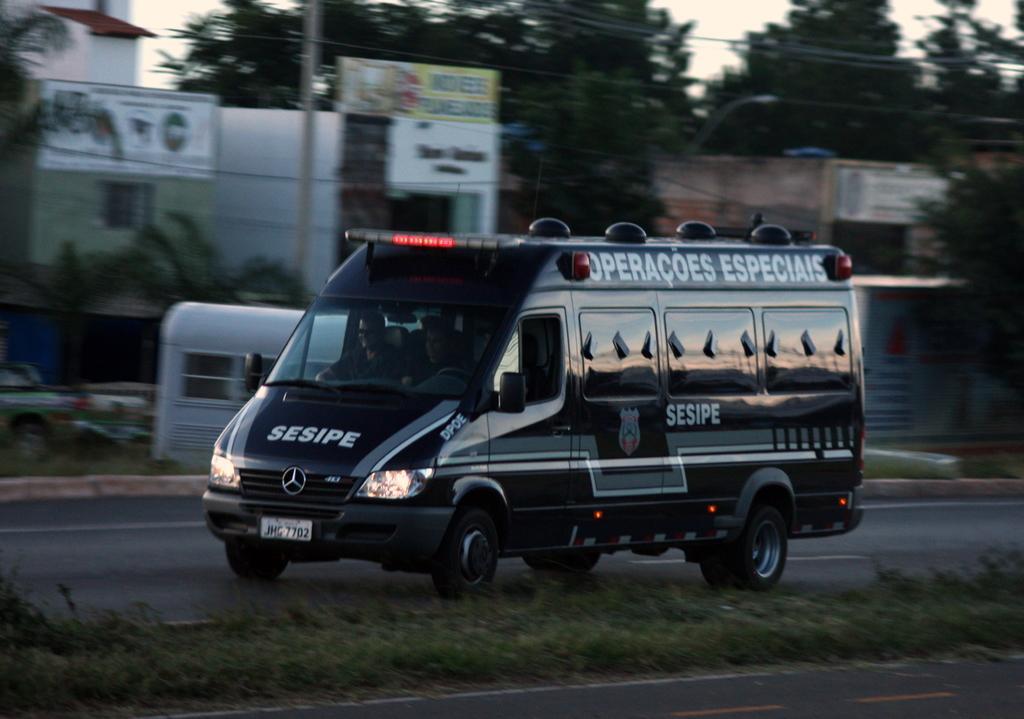Can you describe this image briefly? There is a vehicle with something written on that. It is on a road. Near to the road there is grass. In the back there are buildings with banners. In the background there are trees and sky. Also there are few vehicles. 